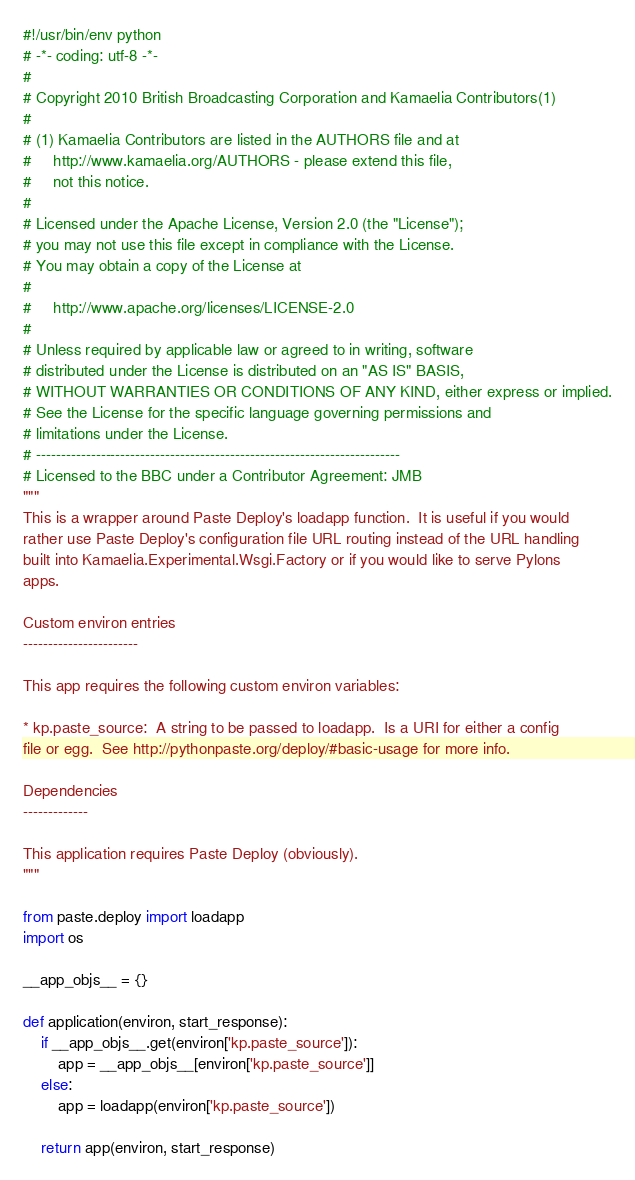<code> <loc_0><loc_0><loc_500><loc_500><_Python_>#!/usr/bin/env python
# -*- coding: utf-8 -*-
#
# Copyright 2010 British Broadcasting Corporation and Kamaelia Contributors(1)
#
# (1) Kamaelia Contributors are listed in the AUTHORS file and at
#     http://www.kamaelia.org/AUTHORS - please extend this file,
#     not this notice.
#
# Licensed under the Apache License, Version 2.0 (the "License");
# you may not use this file except in compliance with the License.
# You may obtain a copy of the License at
#
#     http://www.apache.org/licenses/LICENSE-2.0
#
# Unless required by applicable law or agreed to in writing, software
# distributed under the License is distributed on an "AS IS" BASIS,
# WITHOUT WARRANTIES OR CONDITIONS OF ANY KIND, either express or implied.
# See the License for the specific language governing permissions and
# limitations under the License.
# -------------------------------------------------------------------------
# Licensed to the BBC under a Contributor Agreement: JMB
"""
This is a wrapper around Paste Deploy's loadapp function.  It is useful if you would
rather use Paste Deploy's configuration file URL routing instead of the URL handling
built into Kamaelia.Experimental.Wsgi.Factory or if you would like to serve Pylons
apps.

Custom environ entries
-----------------------

This app requires the following custom environ variables:

* kp.paste_source:  A string to be passed to loadapp.  Is a URI for either a config
file or egg.  See http://pythonpaste.org/deploy/#basic-usage for more info.

Dependencies
-------------

This application requires Paste Deploy (obviously).
"""

from paste.deploy import loadapp
import os

__app_objs__ = {}

def application(environ, start_response):
    if __app_objs__.get(environ['kp.paste_source']):
        app = __app_objs__[environ['kp.paste_source']]
    else:
        app = loadapp(environ['kp.paste_source'])
        
    return app(environ, start_response)
</code> 